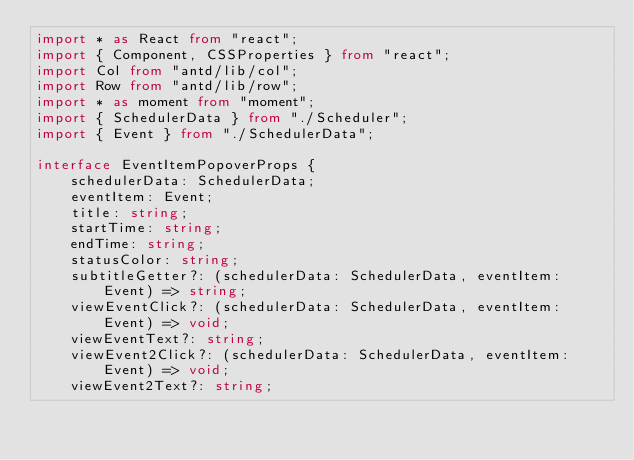<code> <loc_0><loc_0><loc_500><loc_500><_TypeScript_>import * as React from "react";
import { Component, CSSProperties } from "react";
import Col from "antd/lib/col";
import Row from "antd/lib/row";
import * as moment from "moment";
import { SchedulerData } from "./Scheduler";
import { Event } from "./SchedulerData";

interface EventItemPopoverProps {
    schedulerData: SchedulerData;
    eventItem: Event;
    title: string;
    startTime: string;
    endTime: string;
    statusColor: string;
    subtitleGetter?: (schedulerData: SchedulerData, eventItem: Event) => string;
    viewEventClick?: (schedulerData: SchedulerData, eventItem: Event) => void;
    viewEventText?: string;
    viewEvent2Click?: (schedulerData: SchedulerData, eventItem: Event) => void;
    viewEvent2Text?: string;</code> 